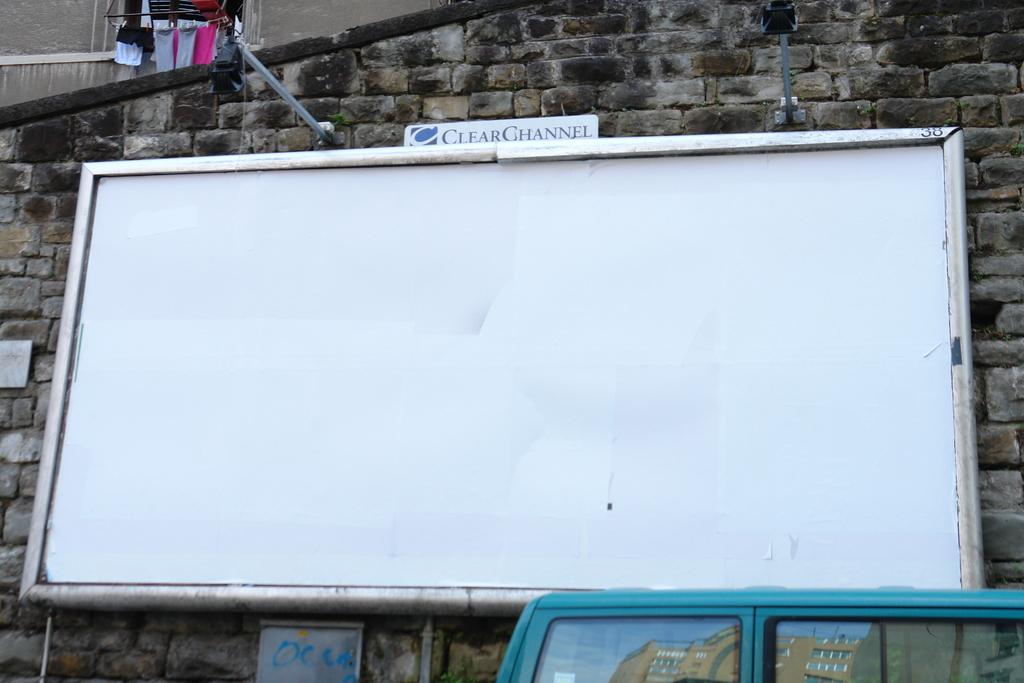<image>
Present a compact description of the photo's key features. A large white board on a brick wall is sponsored by Clear Channel. 